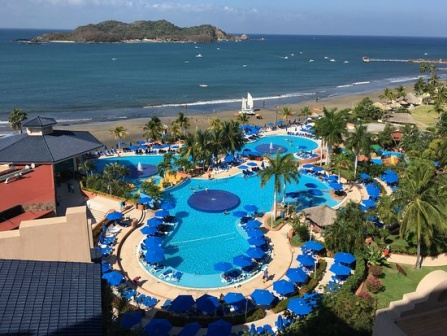Imagine that the resort offers a night-time illumination show at the pool area. Describe what this show might look like and how it would enrich the guest experience. A night-time illumination show at the resort’s pool area would be an enchanting spectacle, adding a magical dimension to the guest experience. As night falls, the pool transforms into a canvas for a dazzling display of lights and colors, synchronized to a harmonious soundtrack that reverberates softly through the surroundings.

The show might begin with gentle, shifting hues of blue and green, mimicking the serene movements of the ocean. Delicate patterns and shapes dance across the water’s surface, creating a mesmerizing effect that captivates guests. As the music builds, the lights become more dynamic, introducing vibrant splashes of red, yellow, and purple, interweaving to form intricate, flowing designs that move in time with the rhythm.

Laser lights might be used to cast beams of light across the area, creating an ethereal atmosphere as they crisscross over the pool and surrounding palm trees. Projection mapping onto the buildings and structures could add another layer of visual delight, with animated scenes unfolding seamlessly on their surfaces, telling stories or depicting abstract art.

To further enrich the experience, the resort might incorporate elements like water fountains or mist sprayers, adding texture and depth to the light show. These could be programmed to spout or mist in sync with the music and lights, creating a multi-sensory performance that envelops the audience.

The grand finale could involve a burst of brighter lights and more upbeat music, culminating in a spectacular crescendo that leaves guests in awe. The ambiance created by such a show would be one of wonder and enchantment, turning an ordinary night into an unforgettable experience. This nightly illumination show would attract guests of all ages, providing a beautiful, shared experience that enhances the overall allure and charm of the resort. 